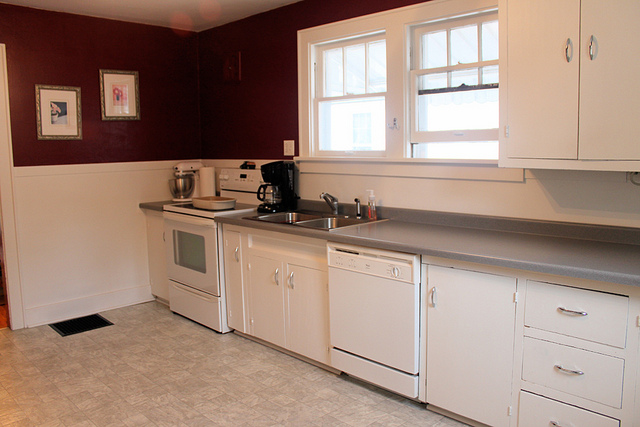Can you describe the lighting in the kitchen? The lighting in the kitchen appears to be primarily natural light coming from the window above the sink, which brightens the space and creates a welcoming atmosphere. Is there any artificial lighting visible? There are overhead lights which are not turned on in the image, but they likely provide additional illumination when needed, especially in the evenings. 